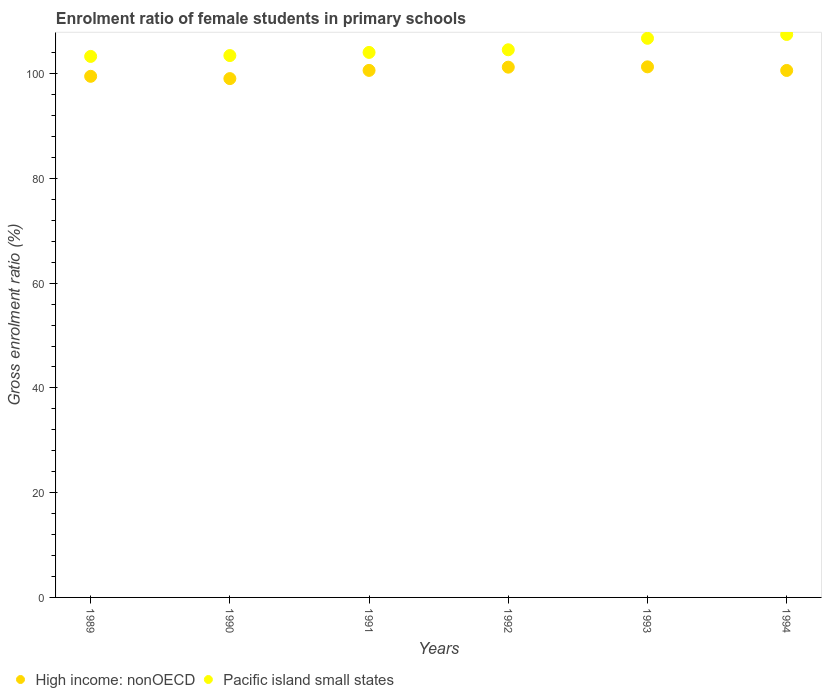What is the enrolment ratio of female students in primary schools in High income: nonOECD in 1993?
Provide a succinct answer. 101.31. Across all years, what is the maximum enrolment ratio of female students in primary schools in High income: nonOECD?
Provide a succinct answer. 101.31. Across all years, what is the minimum enrolment ratio of female students in primary schools in High income: nonOECD?
Give a very brief answer. 99.07. In which year was the enrolment ratio of female students in primary schools in Pacific island small states minimum?
Offer a terse response. 1989. What is the total enrolment ratio of female students in primary schools in High income: nonOECD in the graph?
Offer a terse response. 602.38. What is the difference between the enrolment ratio of female students in primary schools in High income: nonOECD in 1991 and that in 1994?
Give a very brief answer. 0.01. What is the difference between the enrolment ratio of female students in primary schools in High income: nonOECD in 1993 and the enrolment ratio of female students in primary schools in Pacific island small states in 1991?
Keep it short and to the point. -2.75. What is the average enrolment ratio of female students in primary schools in High income: nonOECD per year?
Give a very brief answer. 100.4. In the year 1991, what is the difference between the enrolment ratio of female students in primary schools in Pacific island small states and enrolment ratio of female students in primary schools in High income: nonOECD?
Provide a short and direct response. 3.43. What is the ratio of the enrolment ratio of female students in primary schools in Pacific island small states in 1990 to that in 1994?
Provide a short and direct response. 0.96. Is the enrolment ratio of female students in primary schools in High income: nonOECD in 1991 less than that in 1993?
Offer a very short reply. Yes. Is the difference between the enrolment ratio of female students in primary schools in Pacific island small states in 1989 and 1992 greater than the difference between the enrolment ratio of female students in primary schools in High income: nonOECD in 1989 and 1992?
Keep it short and to the point. Yes. What is the difference between the highest and the second highest enrolment ratio of female students in primary schools in High income: nonOECD?
Your answer should be compact. 0.06. What is the difference between the highest and the lowest enrolment ratio of female students in primary schools in Pacific island small states?
Provide a short and direct response. 4.19. In how many years, is the enrolment ratio of female students in primary schools in High income: nonOECD greater than the average enrolment ratio of female students in primary schools in High income: nonOECD taken over all years?
Offer a very short reply. 4. Does the enrolment ratio of female students in primary schools in Pacific island small states monotonically increase over the years?
Provide a succinct answer. Yes. Is the enrolment ratio of female students in primary schools in Pacific island small states strictly greater than the enrolment ratio of female students in primary schools in High income: nonOECD over the years?
Your answer should be compact. Yes. Is the enrolment ratio of female students in primary schools in High income: nonOECD strictly less than the enrolment ratio of female students in primary schools in Pacific island small states over the years?
Give a very brief answer. Yes. How many dotlines are there?
Ensure brevity in your answer.  2. What is the difference between two consecutive major ticks on the Y-axis?
Keep it short and to the point. 20. Does the graph contain grids?
Your response must be concise. No. How many legend labels are there?
Offer a terse response. 2. What is the title of the graph?
Provide a succinct answer. Enrolment ratio of female students in primary schools. What is the label or title of the X-axis?
Offer a terse response. Years. What is the label or title of the Y-axis?
Your response must be concise. Gross enrolment ratio (%). What is the Gross enrolment ratio (%) in High income: nonOECD in 1989?
Ensure brevity in your answer.  99.5. What is the Gross enrolment ratio (%) in Pacific island small states in 1989?
Your response must be concise. 103.3. What is the Gross enrolment ratio (%) in High income: nonOECD in 1990?
Give a very brief answer. 99.07. What is the Gross enrolment ratio (%) of Pacific island small states in 1990?
Give a very brief answer. 103.46. What is the Gross enrolment ratio (%) in High income: nonOECD in 1991?
Make the answer very short. 100.63. What is the Gross enrolment ratio (%) in Pacific island small states in 1991?
Offer a very short reply. 104.06. What is the Gross enrolment ratio (%) in High income: nonOECD in 1992?
Your answer should be very brief. 101.25. What is the Gross enrolment ratio (%) of Pacific island small states in 1992?
Your answer should be very brief. 104.57. What is the Gross enrolment ratio (%) of High income: nonOECD in 1993?
Your answer should be compact. 101.31. What is the Gross enrolment ratio (%) in Pacific island small states in 1993?
Keep it short and to the point. 106.76. What is the Gross enrolment ratio (%) of High income: nonOECD in 1994?
Keep it short and to the point. 100.62. What is the Gross enrolment ratio (%) of Pacific island small states in 1994?
Provide a short and direct response. 107.49. Across all years, what is the maximum Gross enrolment ratio (%) of High income: nonOECD?
Make the answer very short. 101.31. Across all years, what is the maximum Gross enrolment ratio (%) in Pacific island small states?
Provide a succinct answer. 107.49. Across all years, what is the minimum Gross enrolment ratio (%) in High income: nonOECD?
Make the answer very short. 99.07. Across all years, what is the minimum Gross enrolment ratio (%) in Pacific island small states?
Keep it short and to the point. 103.3. What is the total Gross enrolment ratio (%) in High income: nonOECD in the graph?
Make the answer very short. 602.38. What is the total Gross enrolment ratio (%) of Pacific island small states in the graph?
Offer a terse response. 629.65. What is the difference between the Gross enrolment ratio (%) in High income: nonOECD in 1989 and that in 1990?
Your response must be concise. 0.44. What is the difference between the Gross enrolment ratio (%) in Pacific island small states in 1989 and that in 1990?
Offer a very short reply. -0.16. What is the difference between the Gross enrolment ratio (%) of High income: nonOECD in 1989 and that in 1991?
Offer a very short reply. -1.13. What is the difference between the Gross enrolment ratio (%) in Pacific island small states in 1989 and that in 1991?
Keep it short and to the point. -0.76. What is the difference between the Gross enrolment ratio (%) in High income: nonOECD in 1989 and that in 1992?
Offer a terse response. -1.75. What is the difference between the Gross enrolment ratio (%) of Pacific island small states in 1989 and that in 1992?
Offer a very short reply. -1.27. What is the difference between the Gross enrolment ratio (%) in High income: nonOECD in 1989 and that in 1993?
Offer a very short reply. -1.81. What is the difference between the Gross enrolment ratio (%) of Pacific island small states in 1989 and that in 1993?
Your response must be concise. -3.46. What is the difference between the Gross enrolment ratio (%) of High income: nonOECD in 1989 and that in 1994?
Give a very brief answer. -1.12. What is the difference between the Gross enrolment ratio (%) in Pacific island small states in 1989 and that in 1994?
Your answer should be very brief. -4.19. What is the difference between the Gross enrolment ratio (%) of High income: nonOECD in 1990 and that in 1991?
Make the answer very short. -1.57. What is the difference between the Gross enrolment ratio (%) in Pacific island small states in 1990 and that in 1991?
Your answer should be very brief. -0.6. What is the difference between the Gross enrolment ratio (%) of High income: nonOECD in 1990 and that in 1992?
Make the answer very short. -2.18. What is the difference between the Gross enrolment ratio (%) of Pacific island small states in 1990 and that in 1992?
Ensure brevity in your answer.  -1.1. What is the difference between the Gross enrolment ratio (%) in High income: nonOECD in 1990 and that in 1993?
Your answer should be compact. -2.24. What is the difference between the Gross enrolment ratio (%) of Pacific island small states in 1990 and that in 1993?
Provide a succinct answer. -3.3. What is the difference between the Gross enrolment ratio (%) in High income: nonOECD in 1990 and that in 1994?
Make the answer very short. -1.55. What is the difference between the Gross enrolment ratio (%) of Pacific island small states in 1990 and that in 1994?
Offer a terse response. -4.03. What is the difference between the Gross enrolment ratio (%) in High income: nonOECD in 1991 and that in 1992?
Your response must be concise. -0.62. What is the difference between the Gross enrolment ratio (%) of Pacific island small states in 1991 and that in 1992?
Provide a short and direct response. -0.5. What is the difference between the Gross enrolment ratio (%) of High income: nonOECD in 1991 and that in 1993?
Your answer should be very brief. -0.68. What is the difference between the Gross enrolment ratio (%) in Pacific island small states in 1991 and that in 1993?
Give a very brief answer. -2.7. What is the difference between the Gross enrolment ratio (%) in High income: nonOECD in 1991 and that in 1994?
Offer a terse response. 0.01. What is the difference between the Gross enrolment ratio (%) in Pacific island small states in 1991 and that in 1994?
Ensure brevity in your answer.  -3.43. What is the difference between the Gross enrolment ratio (%) of High income: nonOECD in 1992 and that in 1993?
Keep it short and to the point. -0.06. What is the difference between the Gross enrolment ratio (%) of Pacific island small states in 1992 and that in 1993?
Provide a succinct answer. -2.19. What is the difference between the Gross enrolment ratio (%) in High income: nonOECD in 1992 and that in 1994?
Offer a very short reply. 0.63. What is the difference between the Gross enrolment ratio (%) of Pacific island small states in 1992 and that in 1994?
Offer a terse response. -2.93. What is the difference between the Gross enrolment ratio (%) in High income: nonOECD in 1993 and that in 1994?
Offer a very short reply. 0.69. What is the difference between the Gross enrolment ratio (%) of Pacific island small states in 1993 and that in 1994?
Your response must be concise. -0.73. What is the difference between the Gross enrolment ratio (%) in High income: nonOECD in 1989 and the Gross enrolment ratio (%) in Pacific island small states in 1990?
Keep it short and to the point. -3.96. What is the difference between the Gross enrolment ratio (%) in High income: nonOECD in 1989 and the Gross enrolment ratio (%) in Pacific island small states in 1991?
Your answer should be compact. -4.56. What is the difference between the Gross enrolment ratio (%) of High income: nonOECD in 1989 and the Gross enrolment ratio (%) of Pacific island small states in 1992?
Give a very brief answer. -5.07. What is the difference between the Gross enrolment ratio (%) in High income: nonOECD in 1989 and the Gross enrolment ratio (%) in Pacific island small states in 1993?
Offer a terse response. -7.26. What is the difference between the Gross enrolment ratio (%) in High income: nonOECD in 1989 and the Gross enrolment ratio (%) in Pacific island small states in 1994?
Your response must be concise. -7.99. What is the difference between the Gross enrolment ratio (%) in High income: nonOECD in 1990 and the Gross enrolment ratio (%) in Pacific island small states in 1991?
Offer a terse response. -5. What is the difference between the Gross enrolment ratio (%) of High income: nonOECD in 1990 and the Gross enrolment ratio (%) of Pacific island small states in 1992?
Ensure brevity in your answer.  -5.5. What is the difference between the Gross enrolment ratio (%) of High income: nonOECD in 1990 and the Gross enrolment ratio (%) of Pacific island small states in 1993?
Your response must be concise. -7.69. What is the difference between the Gross enrolment ratio (%) of High income: nonOECD in 1990 and the Gross enrolment ratio (%) of Pacific island small states in 1994?
Offer a terse response. -8.43. What is the difference between the Gross enrolment ratio (%) of High income: nonOECD in 1991 and the Gross enrolment ratio (%) of Pacific island small states in 1992?
Provide a short and direct response. -3.94. What is the difference between the Gross enrolment ratio (%) of High income: nonOECD in 1991 and the Gross enrolment ratio (%) of Pacific island small states in 1993?
Your answer should be very brief. -6.13. What is the difference between the Gross enrolment ratio (%) in High income: nonOECD in 1991 and the Gross enrolment ratio (%) in Pacific island small states in 1994?
Make the answer very short. -6.86. What is the difference between the Gross enrolment ratio (%) of High income: nonOECD in 1992 and the Gross enrolment ratio (%) of Pacific island small states in 1993?
Your answer should be very brief. -5.51. What is the difference between the Gross enrolment ratio (%) in High income: nonOECD in 1992 and the Gross enrolment ratio (%) in Pacific island small states in 1994?
Keep it short and to the point. -6.24. What is the difference between the Gross enrolment ratio (%) in High income: nonOECD in 1993 and the Gross enrolment ratio (%) in Pacific island small states in 1994?
Offer a terse response. -6.18. What is the average Gross enrolment ratio (%) of High income: nonOECD per year?
Give a very brief answer. 100.4. What is the average Gross enrolment ratio (%) in Pacific island small states per year?
Ensure brevity in your answer.  104.94. In the year 1989, what is the difference between the Gross enrolment ratio (%) of High income: nonOECD and Gross enrolment ratio (%) of Pacific island small states?
Offer a very short reply. -3.8. In the year 1990, what is the difference between the Gross enrolment ratio (%) in High income: nonOECD and Gross enrolment ratio (%) in Pacific island small states?
Give a very brief answer. -4.4. In the year 1991, what is the difference between the Gross enrolment ratio (%) of High income: nonOECD and Gross enrolment ratio (%) of Pacific island small states?
Provide a short and direct response. -3.43. In the year 1992, what is the difference between the Gross enrolment ratio (%) in High income: nonOECD and Gross enrolment ratio (%) in Pacific island small states?
Provide a succinct answer. -3.32. In the year 1993, what is the difference between the Gross enrolment ratio (%) of High income: nonOECD and Gross enrolment ratio (%) of Pacific island small states?
Offer a very short reply. -5.45. In the year 1994, what is the difference between the Gross enrolment ratio (%) in High income: nonOECD and Gross enrolment ratio (%) in Pacific island small states?
Ensure brevity in your answer.  -6.87. What is the ratio of the Gross enrolment ratio (%) of High income: nonOECD in 1989 to that in 1990?
Provide a short and direct response. 1. What is the ratio of the Gross enrolment ratio (%) in Pacific island small states in 1989 to that in 1990?
Your answer should be very brief. 1. What is the ratio of the Gross enrolment ratio (%) in High income: nonOECD in 1989 to that in 1991?
Keep it short and to the point. 0.99. What is the ratio of the Gross enrolment ratio (%) in High income: nonOECD in 1989 to that in 1992?
Your response must be concise. 0.98. What is the ratio of the Gross enrolment ratio (%) of Pacific island small states in 1989 to that in 1992?
Provide a short and direct response. 0.99. What is the ratio of the Gross enrolment ratio (%) in High income: nonOECD in 1989 to that in 1993?
Offer a terse response. 0.98. What is the ratio of the Gross enrolment ratio (%) in Pacific island small states in 1989 to that in 1993?
Your response must be concise. 0.97. What is the ratio of the Gross enrolment ratio (%) of High income: nonOECD in 1989 to that in 1994?
Offer a very short reply. 0.99. What is the ratio of the Gross enrolment ratio (%) in High income: nonOECD in 1990 to that in 1991?
Give a very brief answer. 0.98. What is the ratio of the Gross enrolment ratio (%) of High income: nonOECD in 1990 to that in 1992?
Give a very brief answer. 0.98. What is the ratio of the Gross enrolment ratio (%) of Pacific island small states in 1990 to that in 1992?
Provide a succinct answer. 0.99. What is the ratio of the Gross enrolment ratio (%) of High income: nonOECD in 1990 to that in 1993?
Make the answer very short. 0.98. What is the ratio of the Gross enrolment ratio (%) in Pacific island small states in 1990 to that in 1993?
Give a very brief answer. 0.97. What is the ratio of the Gross enrolment ratio (%) in High income: nonOECD in 1990 to that in 1994?
Make the answer very short. 0.98. What is the ratio of the Gross enrolment ratio (%) of Pacific island small states in 1990 to that in 1994?
Provide a succinct answer. 0.96. What is the ratio of the Gross enrolment ratio (%) in High income: nonOECD in 1991 to that in 1993?
Ensure brevity in your answer.  0.99. What is the ratio of the Gross enrolment ratio (%) of Pacific island small states in 1991 to that in 1993?
Your response must be concise. 0.97. What is the ratio of the Gross enrolment ratio (%) in High income: nonOECD in 1991 to that in 1994?
Your response must be concise. 1. What is the ratio of the Gross enrolment ratio (%) of Pacific island small states in 1991 to that in 1994?
Provide a short and direct response. 0.97. What is the ratio of the Gross enrolment ratio (%) in Pacific island small states in 1992 to that in 1993?
Provide a short and direct response. 0.98. What is the ratio of the Gross enrolment ratio (%) of High income: nonOECD in 1992 to that in 1994?
Give a very brief answer. 1.01. What is the ratio of the Gross enrolment ratio (%) in Pacific island small states in 1992 to that in 1994?
Keep it short and to the point. 0.97. What is the ratio of the Gross enrolment ratio (%) of High income: nonOECD in 1993 to that in 1994?
Offer a terse response. 1.01. What is the difference between the highest and the second highest Gross enrolment ratio (%) of High income: nonOECD?
Give a very brief answer. 0.06. What is the difference between the highest and the second highest Gross enrolment ratio (%) of Pacific island small states?
Keep it short and to the point. 0.73. What is the difference between the highest and the lowest Gross enrolment ratio (%) of High income: nonOECD?
Your answer should be compact. 2.24. What is the difference between the highest and the lowest Gross enrolment ratio (%) in Pacific island small states?
Your answer should be compact. 4.19. 